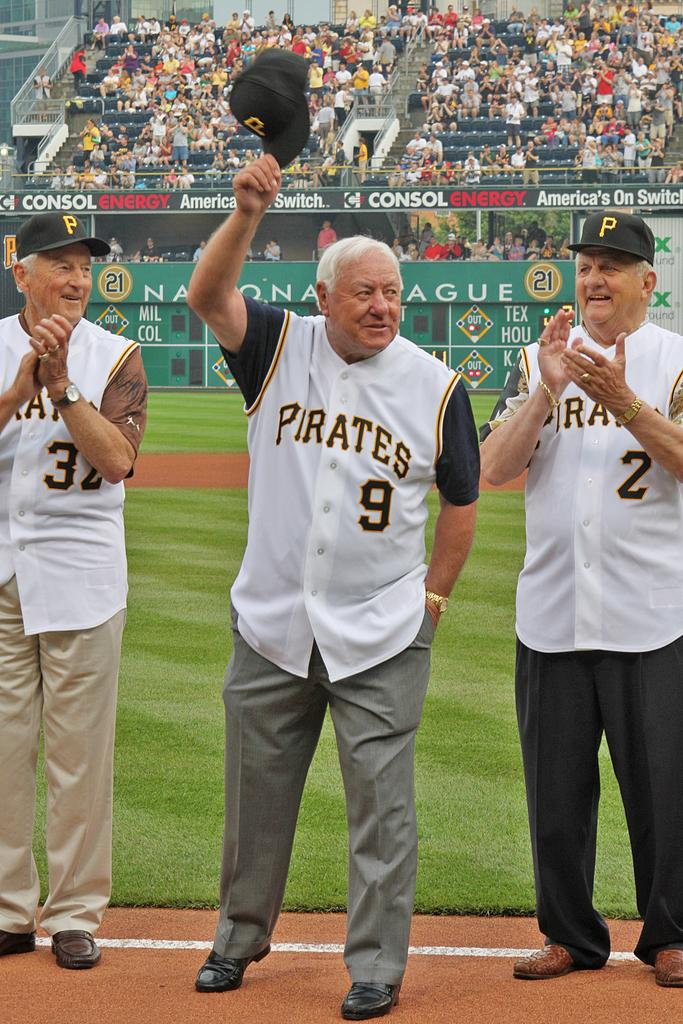<image>
Write a terse but informative summary of the picture. A man wearing a Pirates number 9 jersey acknowledges the crowd as two men clap standing next to him. 